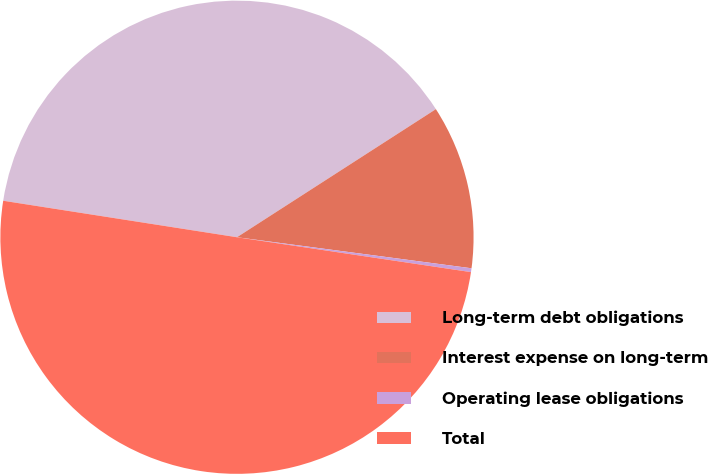<chart> <loc_0><loc_0><loc_500><loc_500><pie_chart><fcel>Long-term debt obligations<fcel>Interest expense on long-term<fcel>Operating lease obligations<fcel>Total<nl><fcel>38.43%<fcel>11.2%<fcel>0.26%<fcel>50.11%<nl></chart> 